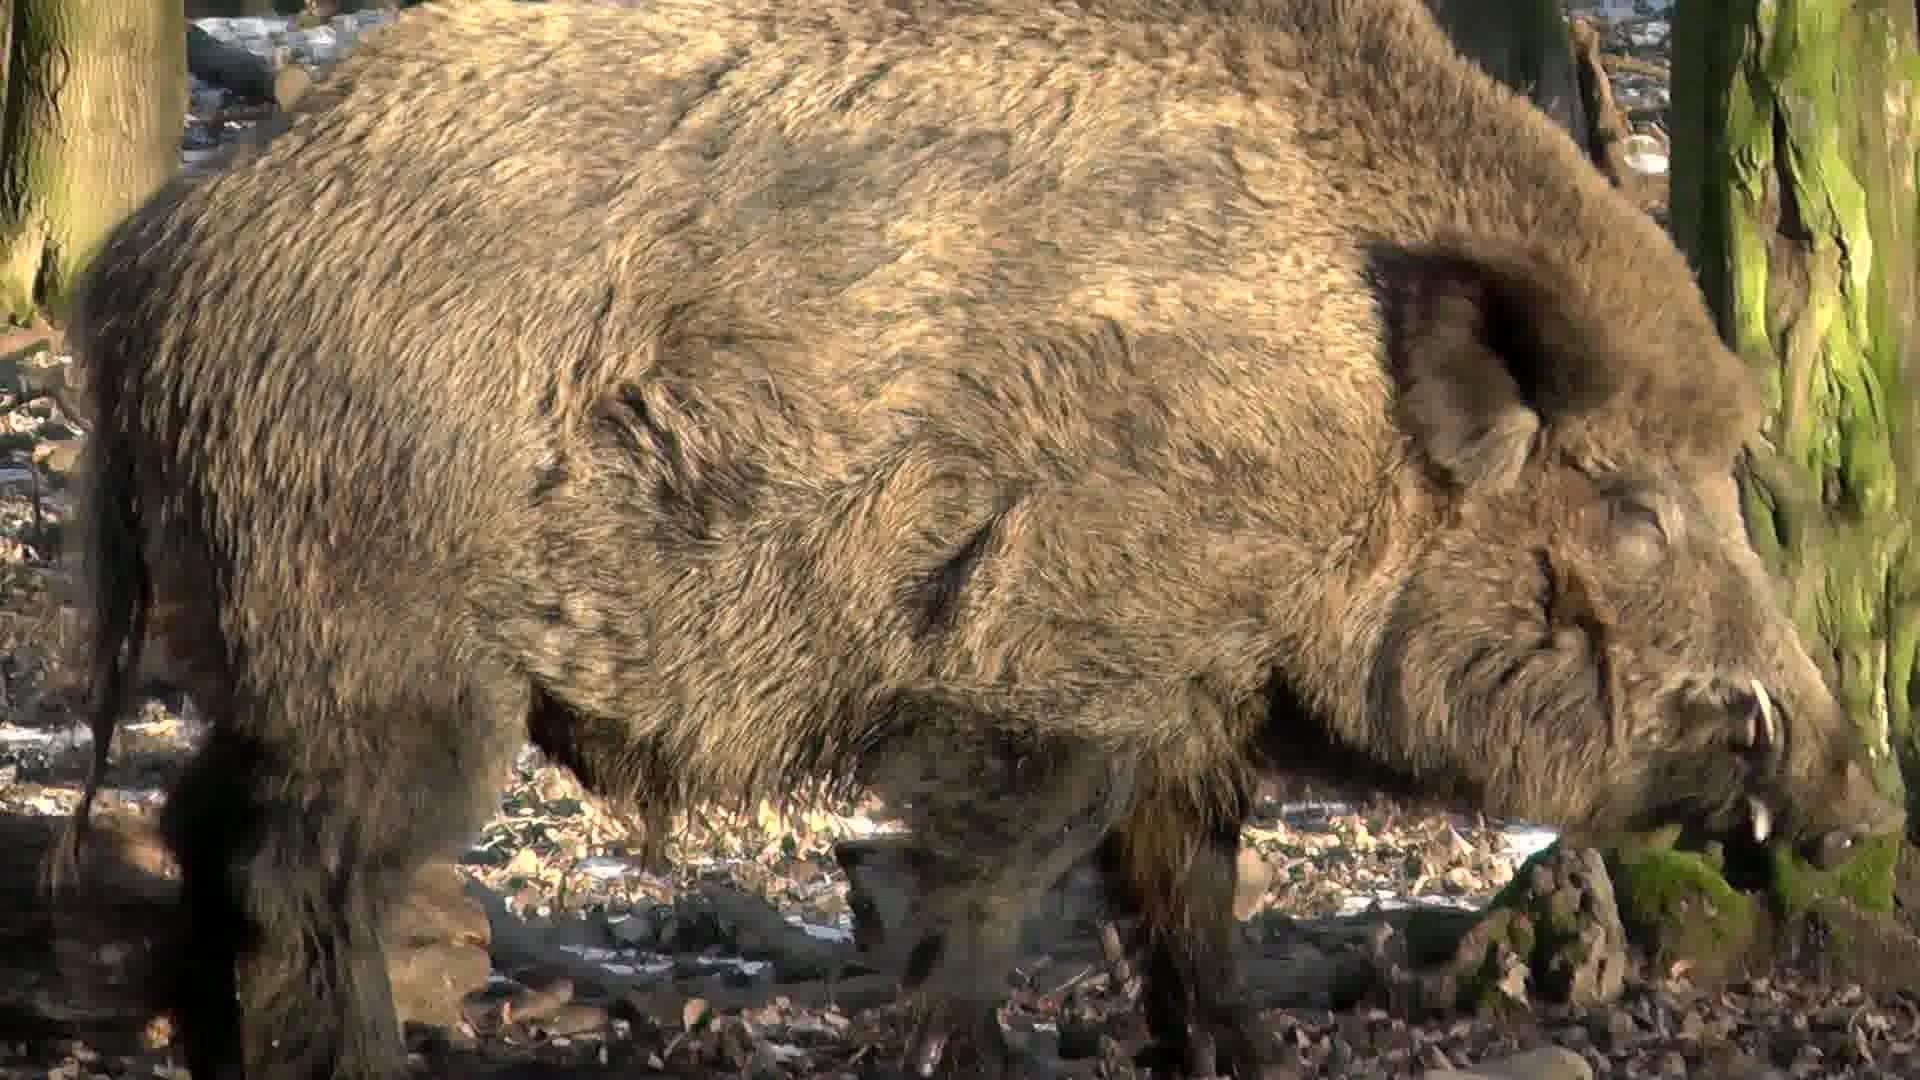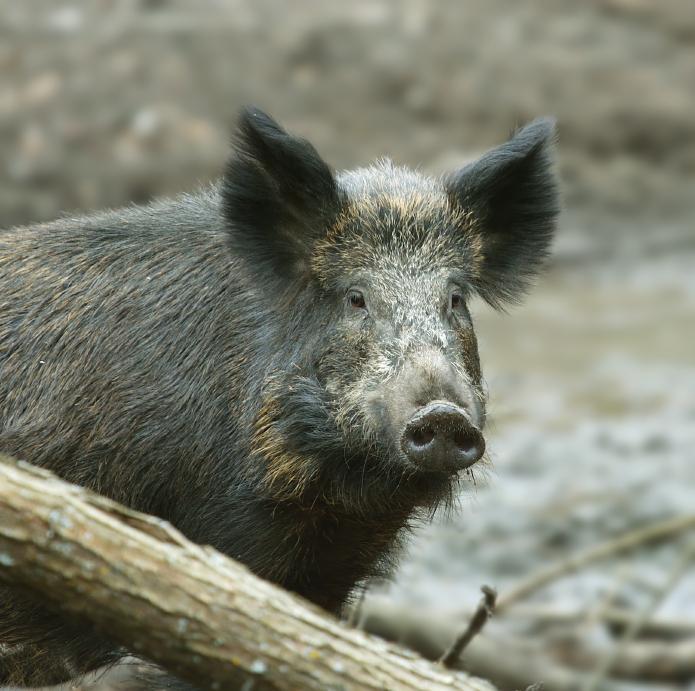The first image is the image on the left, the second image is the image on the right. Examine the images to the left and right. Is the description "There are no more that two pigs standing in lush green grass." accurate? Answer yes or no. No. 